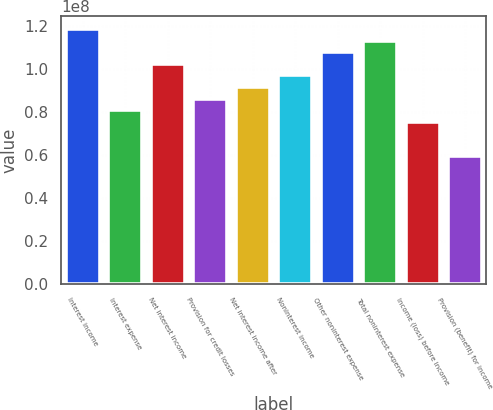Convert chart. <chart><loc_0><loc_0><loc_500><loc_500><bar_chart><fcel>Interest income<fcel>Interest expense<fcel>Net interest income<fcel>Provision for credit losses<fcel>Net interest income after<fcel>Noninterest income<fcel>Other noninterest expense<fcel>Total noninterest expense<fcel>Income (loss) before income<fcel>Provision (benefit) for income<nl><fcel>1.18403e+08<fcel>8.07295e+07<fcel>1.02257e+08<fcel>8.61114e+07<fcel>9.14934e+07<fcel>9.68754e+07<fcel>1.07639e+08<fcel>1.13021e+08<fcel>7.53475e+07<fcel>5.92016e+07<nl></chart> 